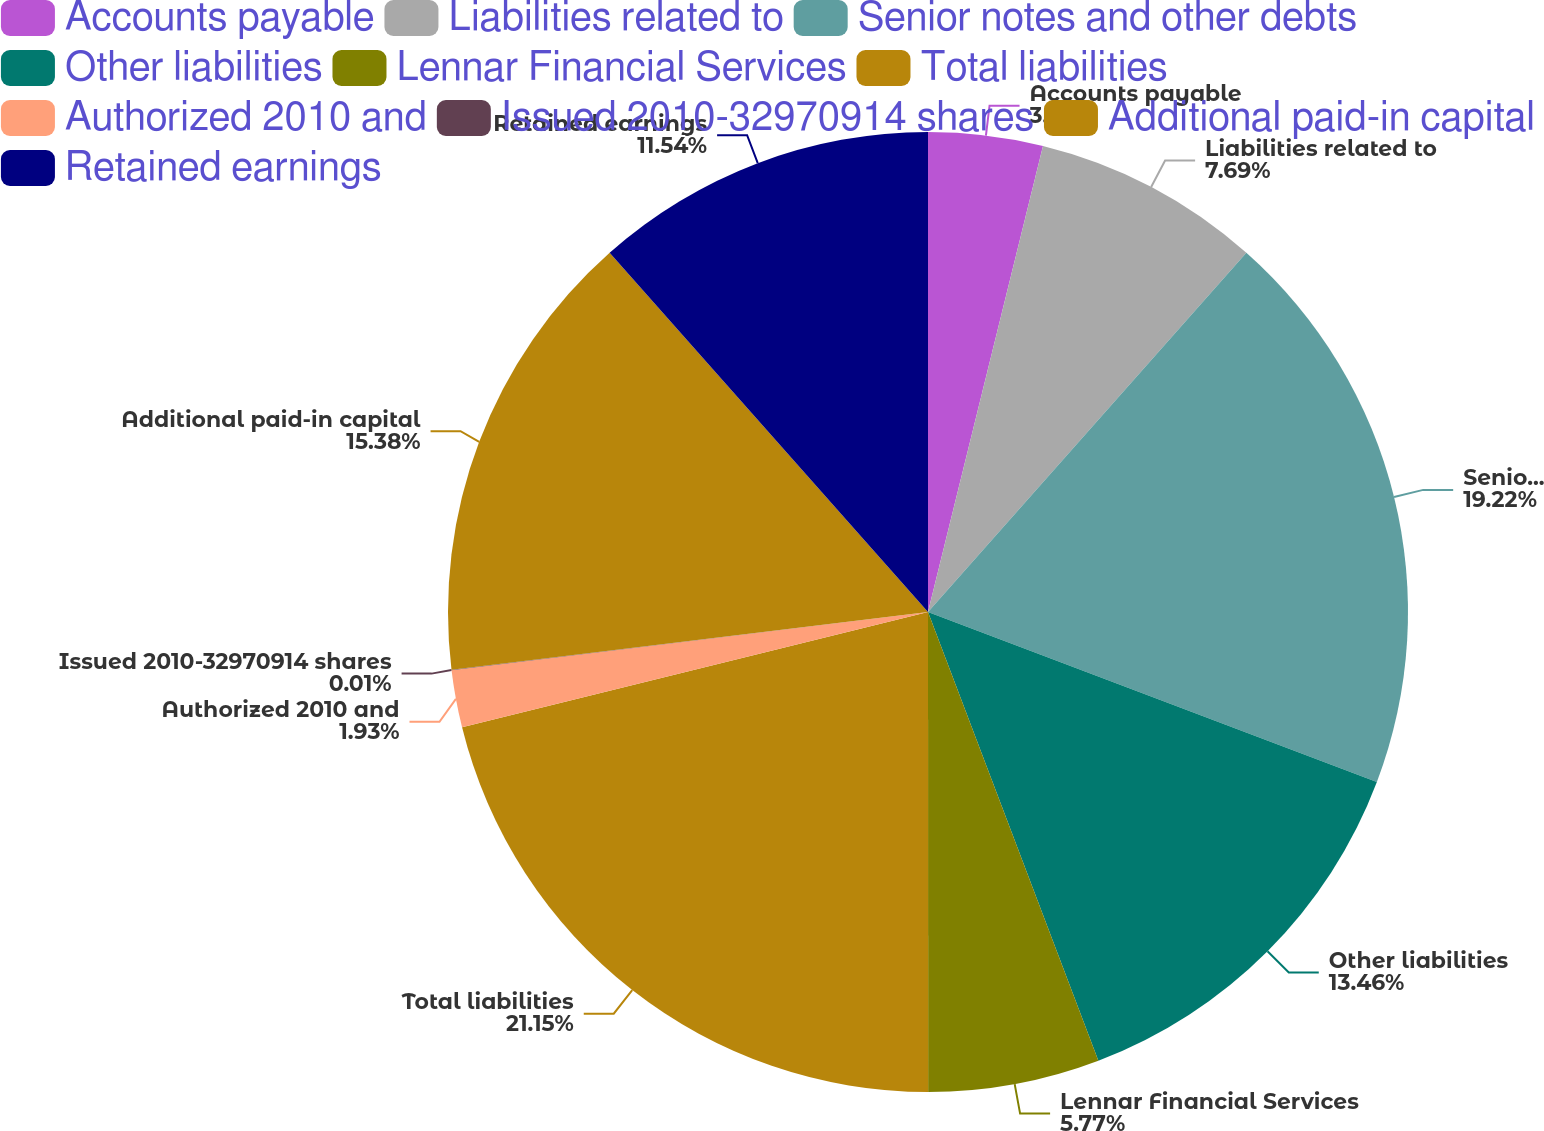Convert chart to OTSL. <chart><loc_0><loc_0><loc_500><loc_500><pie_chart><fcel>Accounts payable<fcel>Liabilities related to<fcel>Senior notes and other debts<fcel>Other liabilities<fcel>Lennar Financial Services<fcel>Total liabilities<fcel>Authorized 2010 and<fcel>Issued 2010-32970914 shares<fcel>Additional paid-in capital<fcel>Retained earnings<nl><fcel>3.85%<fcel>7.69%<fcel>19.22%<fcel>13.46%<fcel>5.77%<fcel>21.14%<fcel>1.93%<fcel>0.01%<fcel>15.38%<fcel>11.54%<nl></chart> 